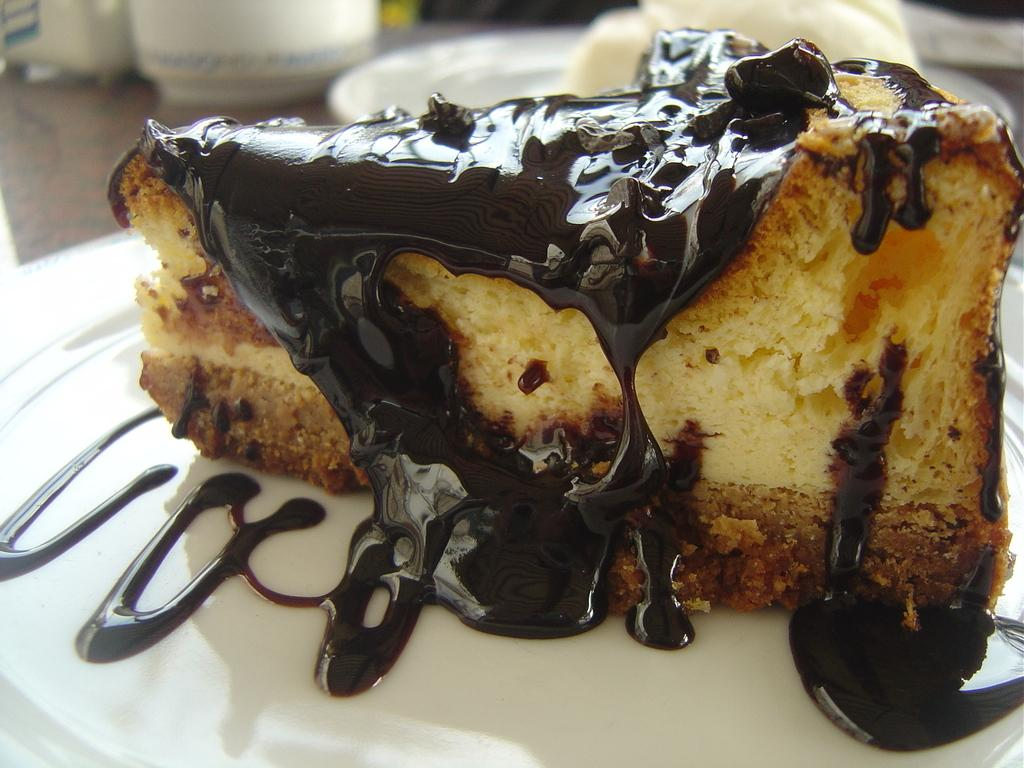What is on the plates that are visible in the image? There are plates with food on them in the image. Can you describe any other tableware or dishware in the image? There are bowls visible in the background of the image. How many letters are on the plates in the image? There are no letters on the plates in the image; they contain food. 